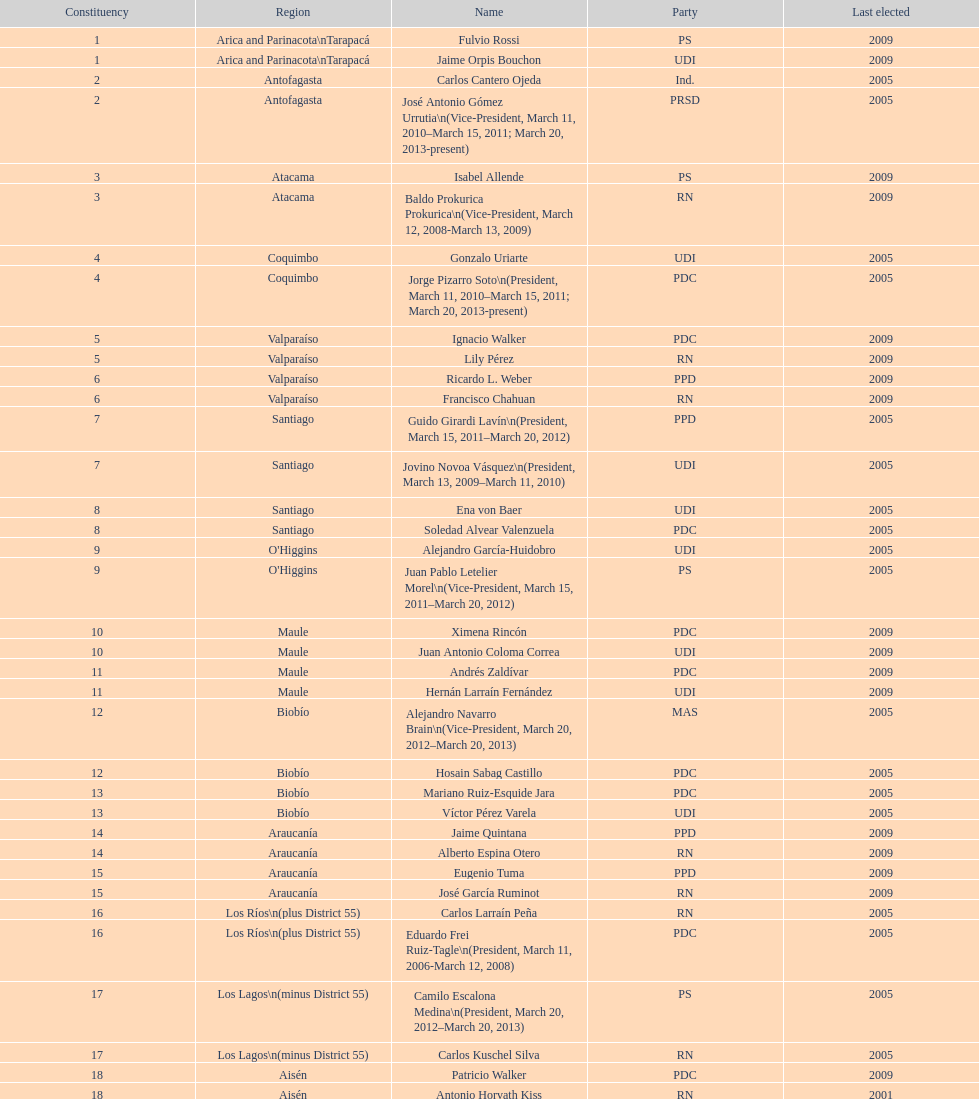What is the total number of constituencies? 19. 